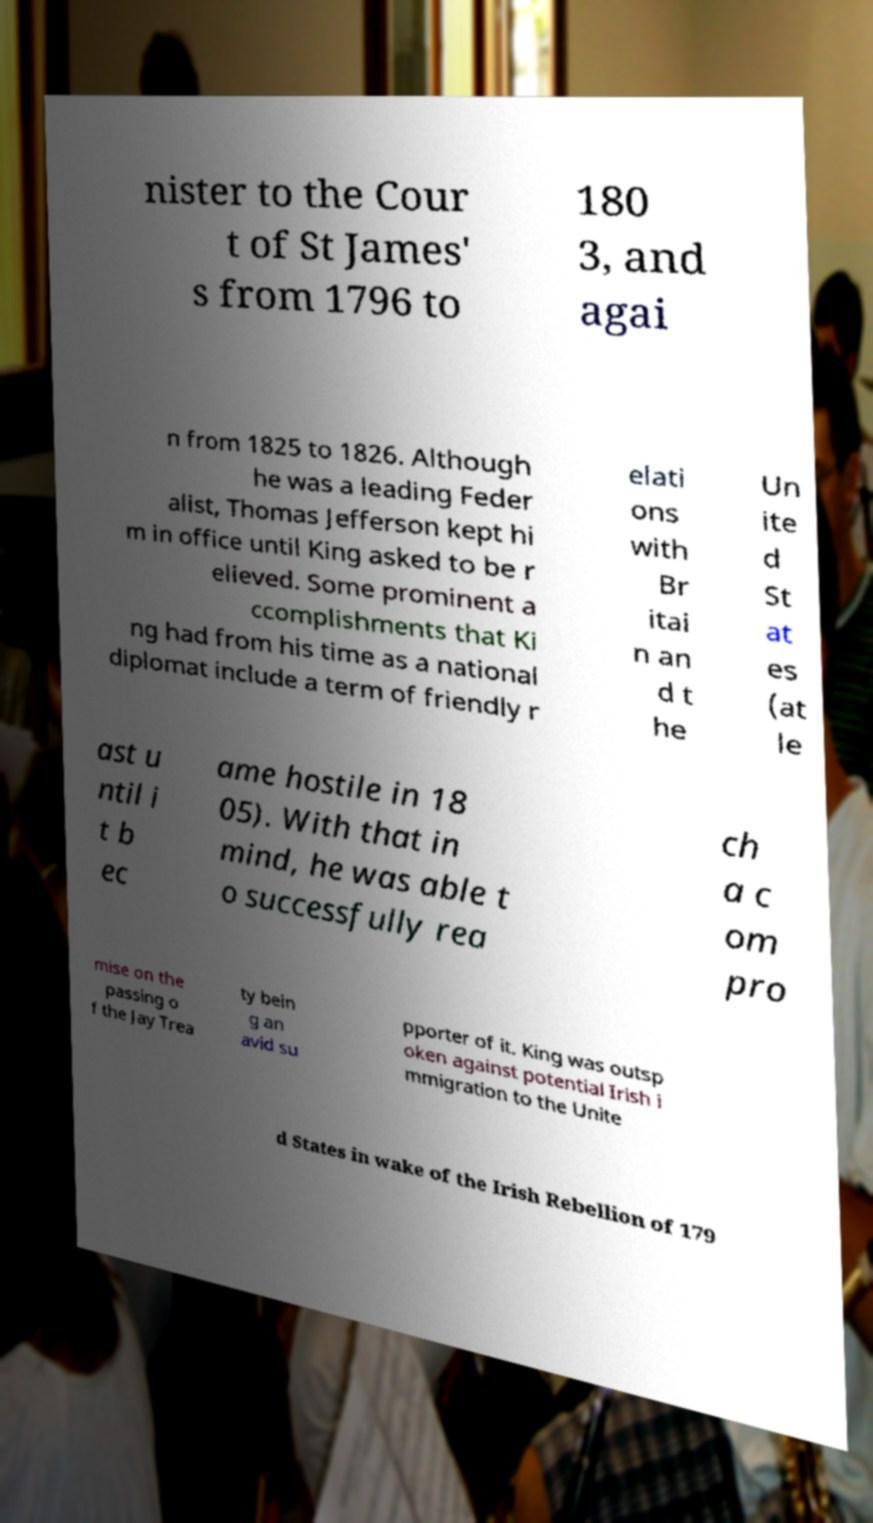Please identify and transcribe the text found in this image. nister to the Cour t of St James' s from 1796 to 180 3, and agai n from 1825 to 1826. Although he was a leading Feder alist, Thomas Jefferson kept hi m in office until King asked to be r elieved. Some prominent a ccomplishments that Ki ng had from his time as a national diplomat include a term of friendly r elati ons with Br itai n an d t he Un ite d St at es (at le ast u ntil i t b ec ame hostile in 18 05). With that in mind, he was able t o successfully rea ch a c om pro mise on the passing o f the Jay Trea ty bein g an avid su pporter of it. King was outsp oken against potential Irish i mmigration to the Unite d States in wake of the Irish Rebellion of 179 